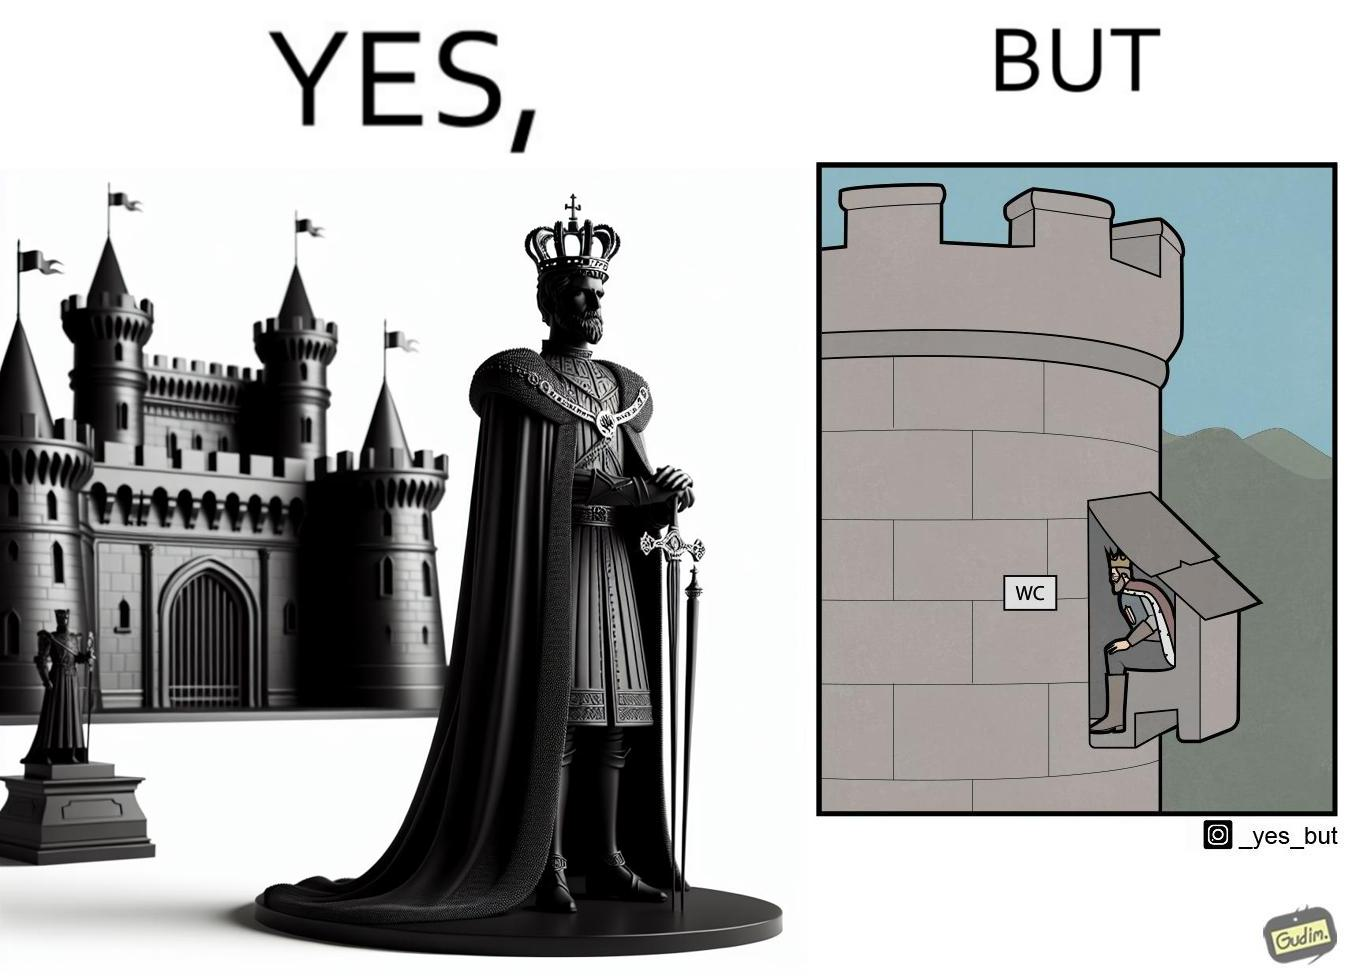What is the satirical meaning behind this image? The images are funny since it shows how even a mighty king must do simple things like using a toilet just like everyone else does 